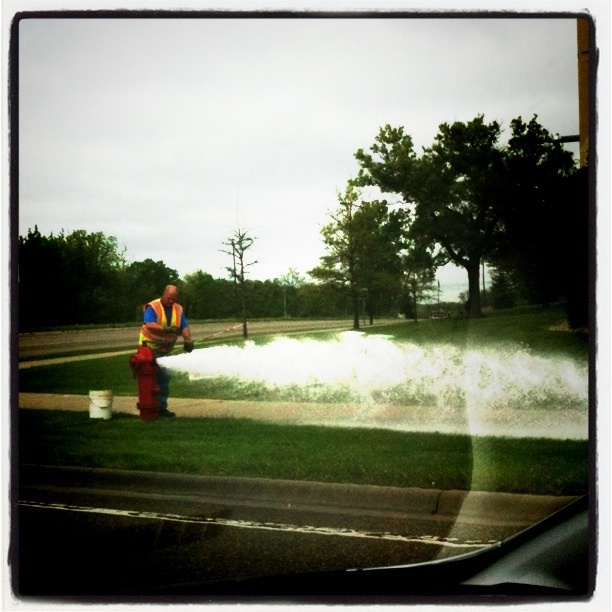Describe the objects in this image and their specific colors. I can see people in white, black, maroon, olive, and brown tones and fire hydrant in white, black, maroon, brown, and olive tones in this image. 